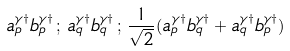Convert formula to latex. <formula><loc_0><loc_0><loc_500><loc_500>a _ { p } ^ { \gamma \dag } b _ { p } ^ { \gamma \dag } \, ; \, a _ { q } ^ { \gamma \dag } b _ { q } ^ { \gamma \dag } \, ; \, \frac { 1 } { \sqrt { 2 } } ( a _ { p } ^ { \gamma \dag } b _ { q } ^ { \gamma \dag } + a _ { q } ^ { \gamma \dag } b _ { p } ^ { \gamma \dag } )</formula> 